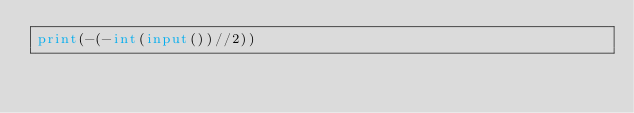<code> <loc_0><loc_0><loc_500><loc_500><_Python_>print(-(-int(input())//2))</code> 